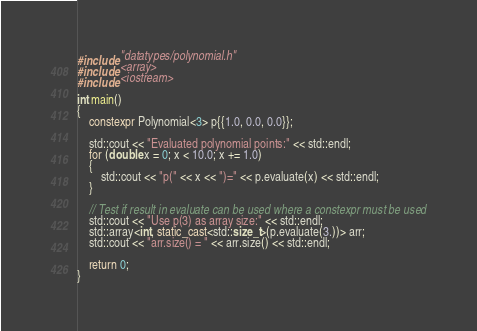<code> <loc_0><loc_0><loc_500><loc_500><_C++_>#include "datatypes/polynomial.h"
#include <array>
#include <iostream>

int main()
{
    constexpr Polynomial<3> p{{1.0, 0.0, 0.0}};

    std::cout << "Evaluated polynomial points:" << std::endl;
    for (double x = 0; x < 10.0; x += 1.0)
    {
        std::cout << "p(" << x << ")=" << p.evaluate(x) << std::endl;
    }

    // Test if result in evaluate can be used where a constexpr must be used
    std::cout << "Use p(3) as array size:" << std::endl;
    std::array<int, static_cast<std::size_t>(p.evaluate(3.))> arr;
    std::cout << "arr.size() = " << arr.size() << std::endl;

    return 0;
}
</code> 